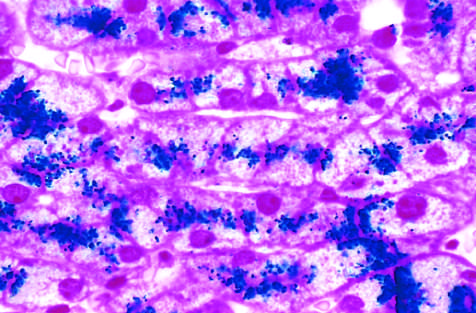what is shown by a special staining process called the prussian blue reaction?
Answer the question using a single word or phrase. Iron deposits 